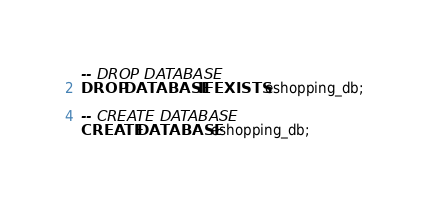Convert code to text. <code><loc_0><loc_0><loc_500><loc_500><_SQL_>-- DROP DATABASE
DROP DATABASE IF EXISTS eshopping_db;

-- CREATE DATABASE
CREATE DATABASE eshopping_db;</code> 